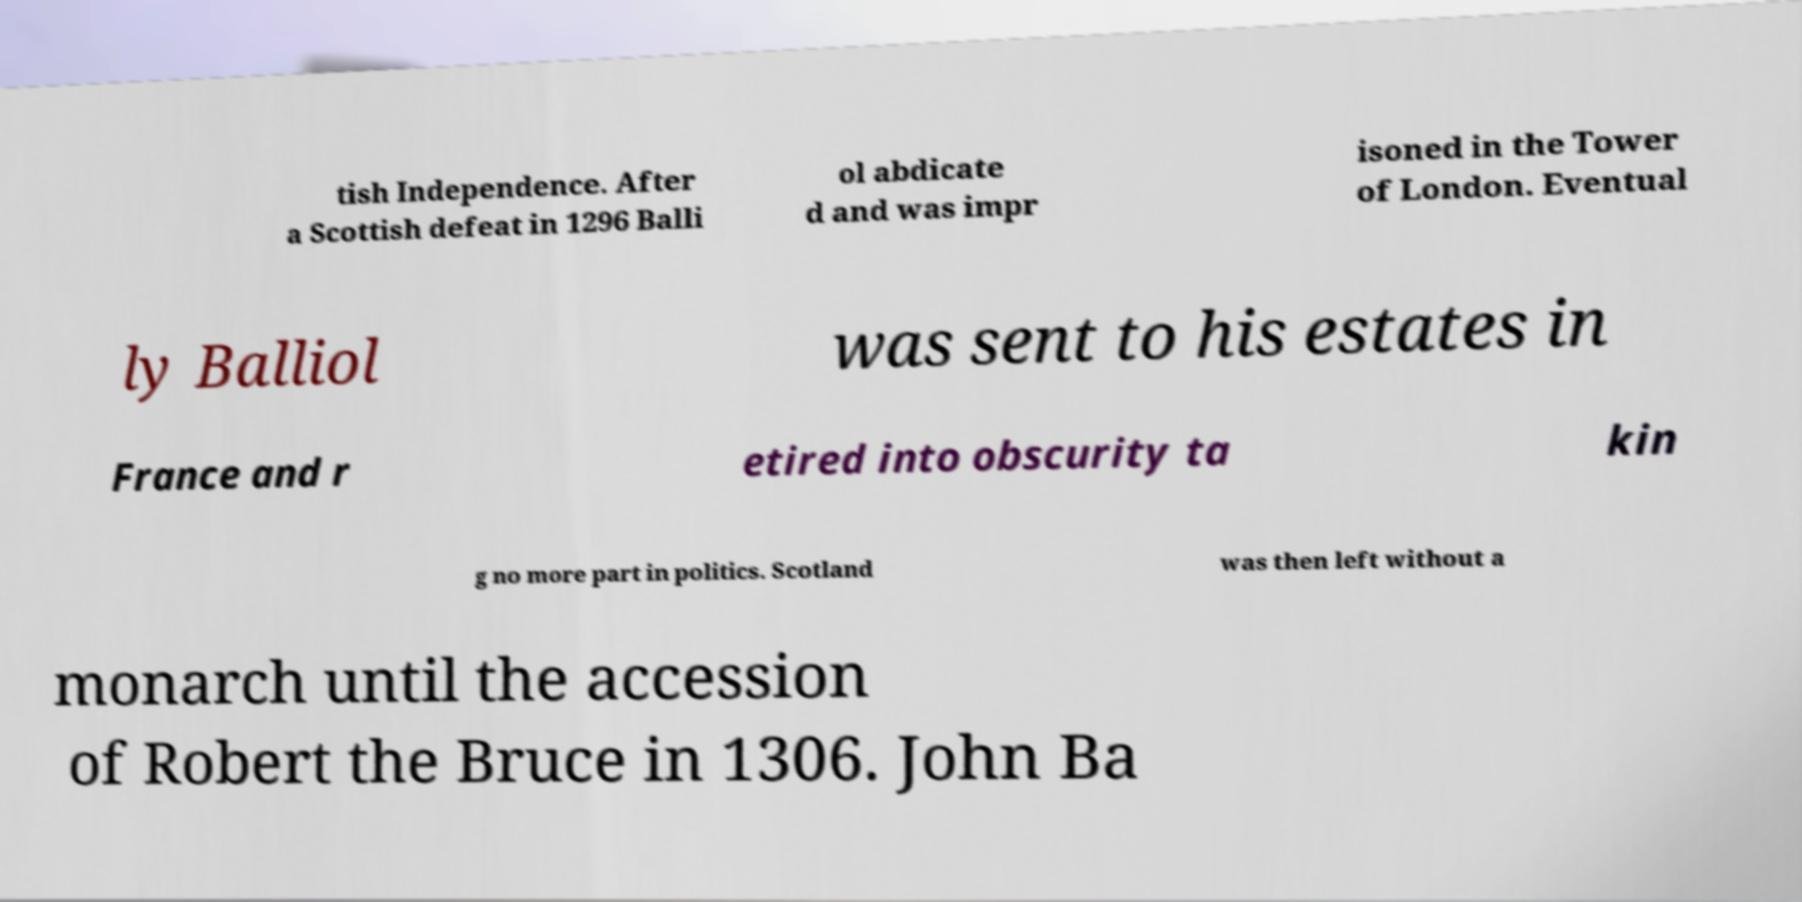What messages or text are displayed in this image? I need them in a readable, typed format. tish Independence. After a Scottish defeat in 1296 Balli ol abdicate d and was impr isoned in the Tower of London. Eventual ly Balliol was sent to his estates in France and r etired into obscurity ta kin g no more part in politics. Scotland was then left without a monarch until the accession of Robert the Bruce in 1306. John Ba 